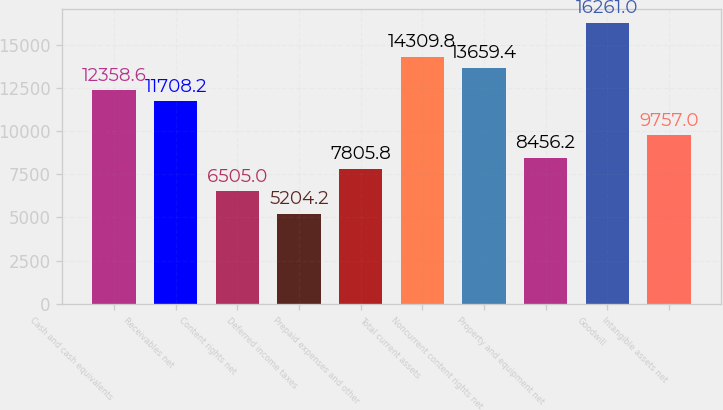Convert chart to OTSL. <chart><loc_0><loc_0><loc_500><loc_500><bar_chart><fcel>Cash and cash equivalents<fcel>Receivables net<fcel>Content rights net<fcel>Deferred income taxes<fcel>Prepaid expenses and other<fcel>Total current assets<fcel>Noncurrent content rights net<fcel>Property and equipment net<fcel>Goodwill<fcel>Intangible assets net<nl><fcel>12358.6<fcel>11708.2<fcel>6505<fcel>5204.2<fcel>7805.8<fcel>14309.8<fcel>13659.4<fcel>8456.2<fcel>16261<fcel>9757<nl></chart> 